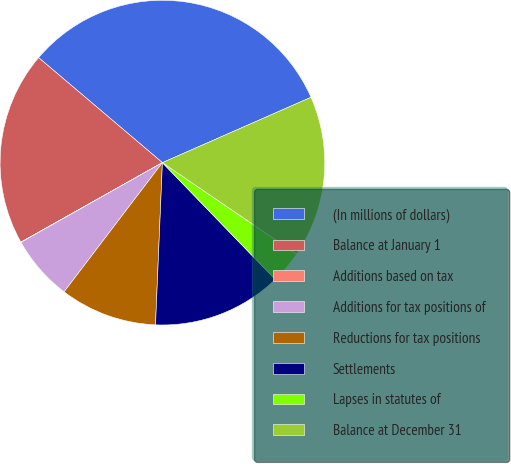<chart> <loc_0><loc_0><loc_500><loc_500><pie_chart><fcel>(In millions of dollars)<fcel>Balance at January 1<fcel>Additions based on tax<fcel>Additions for tax positions of<fcel>Reductions for tax positions<fcel>Settlements<fcel>Lapses in statutes of<fcel>Balance at December 31<nl><fcel>32.21%<fcel>19.34%<fcel>0.03%<fcel>6.47%<fcel>9.68%<fcel>12.9%<fcel>3.25%<fcel>16.12%<nl></chart> 